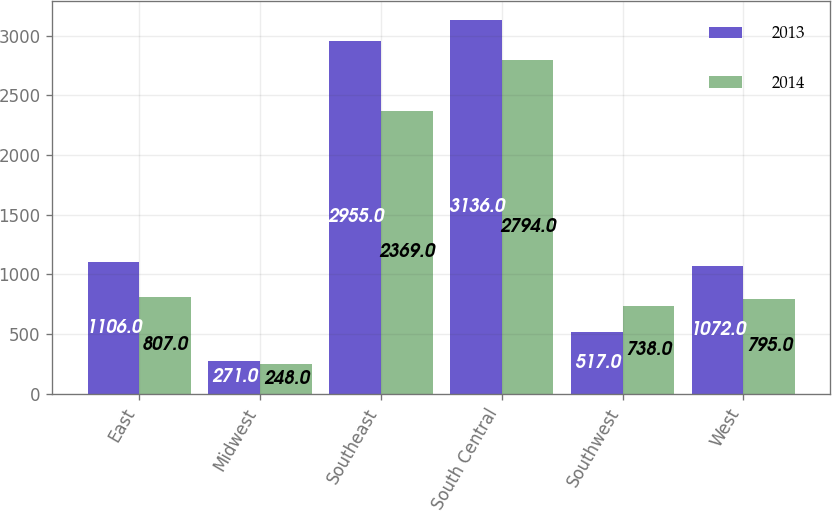Convert chart. <chart><loc_0><loc_0><loc_500><loc_500><stacked_bar_chart><ecel><fcel>East<fcel>Midwest<fcel>Southeast<fcel>South Central<fcel>Southwest<fcel>West<nl><fcel>2013<fcel>1106<fcel>271<fcel>2955<fcel>3136<fcel>517<fcel>1072<nl><fcel>2014<fcel>807<fcel>248<fcel>2369<fcel>2794<fcel>738<fcel>795<nl></chart> 